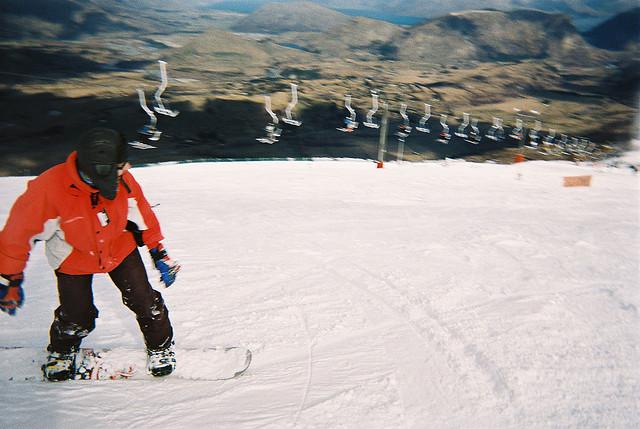Is the weather extreme?
Concise answer only. No. What color is of the jacket?
Write a very short answer. Orange. Is he getting ready to ski?
Quick response, please. No. Is the skier alone?
Concise answer only. Yes. What color is the man's hat?
Keep it brief. Black. Is anyone on the chairlift in the picture?
Answer briefly. Yes. Is there a ski lift in the background?
Quick response, please. Yes. How many snowboarders have boards?
Write a very short answer. 1. 